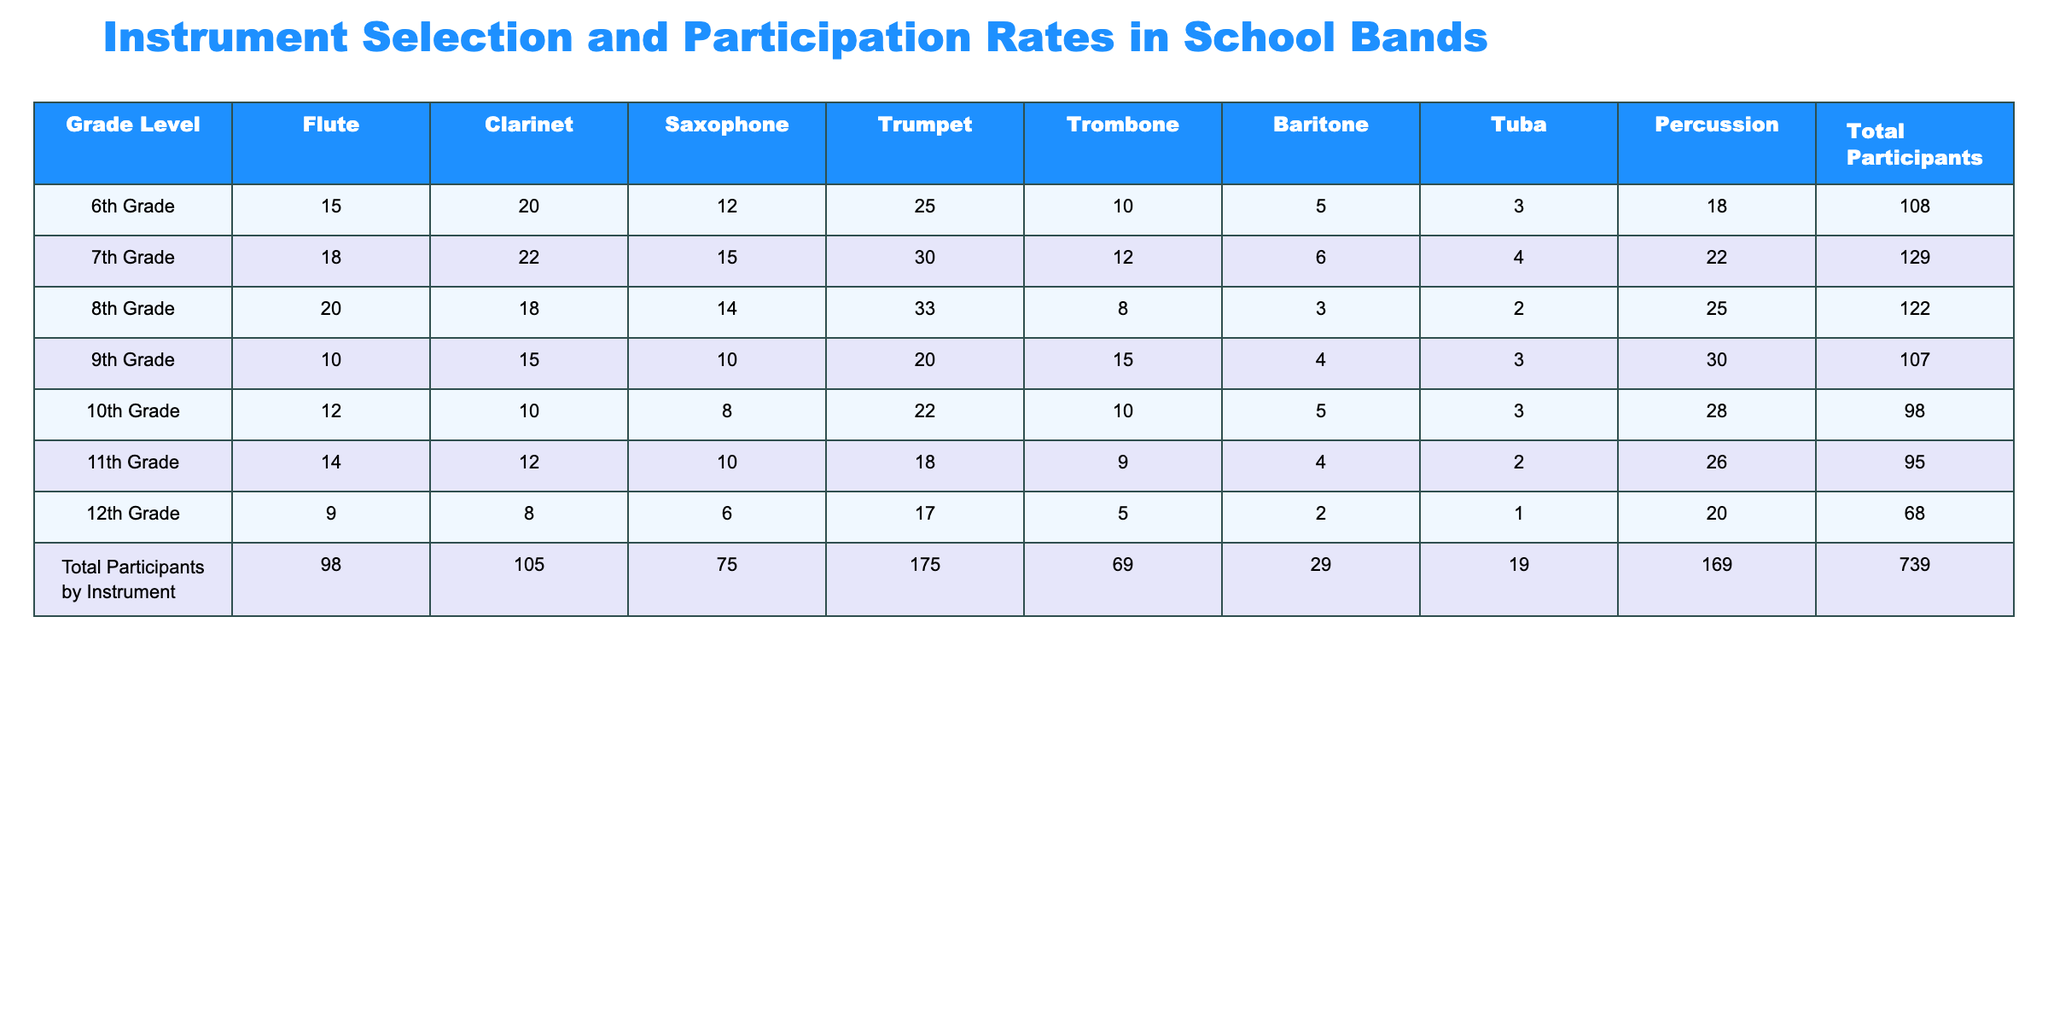What is the total number of participants in the 7th Grade? The table shows that the total participants for the 7th Grade are listed as 129.
Answer: 129 Which instrument has the highest number of participants in total across all grades? By looking at the total participants by instrument row, the trumpet has 175 participants which is the highest.
Answer: Trumpet In which grade level do the most students play the trombone? Referring to the trombone column, the highest number of participants is 15, which occurs in the 9th Grade.
Answer: 9th Grade What is the total for all students playing woodwind instruments (Flute, Clarinet, Saxophone) in 8th Grade? For the 8th Grade, the sum of woodwind participants is 20 (Flute) + 18 (Clarinet) + 14 (Saxophone) = 52.
Answer: 52 Is the number of students playing the tuba in 10th Grade greater than or equal to those in 12th Grade? The number of students playing the tuba in the 10th Grade is 3, and in the 12th Grade, it is 1. Since 3 is greater than 1, the statement is true.
Answer: Yes What is the average number of participants for each instrument across all grades? The sum of participants for each instrument is as follows: Flute (98), Clarinet (105), Saxophone (75), Trumpet (175), Trombone (69), Baritone (29), Tuba (19), Percussion (169). The total number of participants is 739. Therefore, the average for each instrument is calculated by dividing the sum of each instrument's participants by the number of grades (6), resulting in averages of approximately: Flute (16.33), Clarinet (17.5), Saxophone (12.5), Trumpet (29.17), Trombone (11.5), Baritone (4.83), Tuba (3.17), Percussion (28.17).
Answer: Various averages How many more students participate in percussion than in baritone across all grades? The total participants for percussion is 169, and for baritone, it is 29. The difference is 169 - 29 = 140.
Answer: 140 In which grade do students participate the least overall? By comparing the total participants for each grade, the 12th Grade has the smallest number at 68.
Answer: 12th Grade Which instrument has the lowest participation rate in the 11th Grade? The 11th Grade column shows that the instrument with the least participation is tuba, having only 2 students.
Answer: Tuba What is the total number of brass players (Trumpet, Trombone, Baritone, Tuba) in 9th Grade? Adding the participants for the brass instruments in the 9th Grade yields: Trumpet (20) + Trombone (15) + Baritone (4) + Tuba (3) = 42.
Answer: 42 